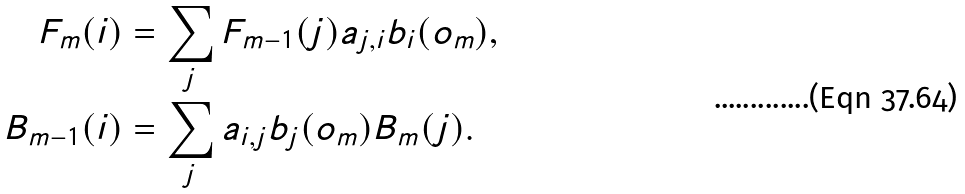<formula> <loc_0><loc_0><loc_500><loc_500>F _ { m } ( i ) & = \sum _ { j } F _ { m - 1 } ( j ) a _ { j , i } b _ { i } ( o _ { m } ) , \\ B _ { m - 1 } ( i ) & = \sum _ { j } a _ { i , j } b _ { j } ( o _ { m } ) B _ { m } ( j ) .</formula> 